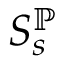Convert formula to latex. <formula><loc_0><loc_0><loc_500><loc_500>S _ { s } ^ { \mathbb { P } }</formula> 